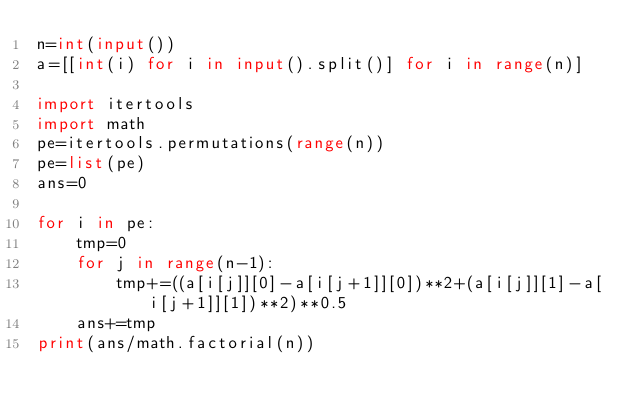Convert code to text. <code><loc_0><loc_0><loc_500><loc_500><_Python_>n=int(input())
a=[[int(i) for i in input().split()] for i in range(n)]

import itertools
import math
pe=itertools.permutations(range(n))
pe=list(pe)
ans=0

for i in pe:
    tmp=0
    for j in range(n-1):
        tmp+=((a[i[j]][0]-a[i[j+1]][0])**2+(a[i[j]][1]-a[i[j+1]][1])**2)**0.5
    ans+=tmp
print(ans/math.factorial(n))</code> 